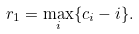<formula> <loc_0><loc_0><loc_500><loc_500>r _ { 1 } = \max _ { i } \{ c _ { i } - i \} .</formula> 